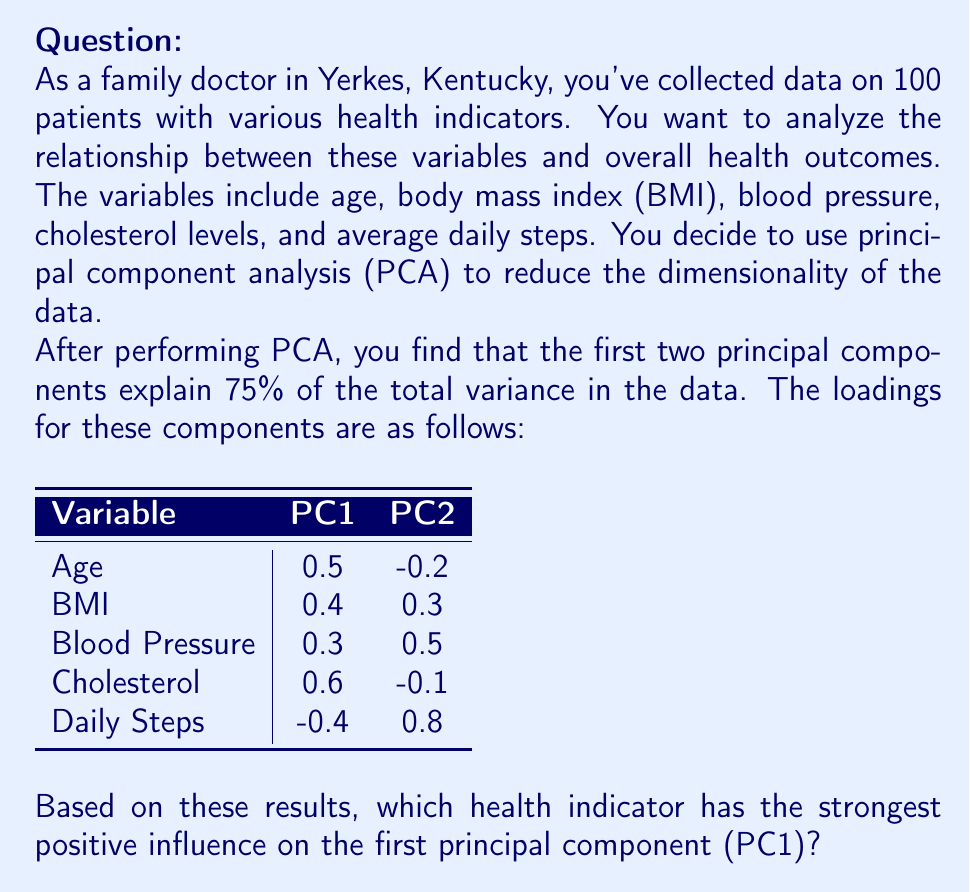Provide a solution to this math problem. To determine which health indicator has the strongest positive influence on PC1, we need to analyze the loadings for each variable in the PC1 column. The loadings represent the correlation between the original variables and the principal components.

Let's examine the loadings for PC1:

1. Age: 0.5
2. BMI: 0.4
3. Blood Pressure: 0.3
4. Cholesterol: 0.6
5. Daily Steps: -0.4

The largest positive loading for PC1 is 0.6, which corresponds to the Cholesterol variable. This means that Cholesterol has the strongest positive influence on the first principal component.

It's worth noting that:
- A positive loading indicates a positive correlation with the principal component.
- The larger the absolute value of the loading, the stronger the influence of that variable on the principal component.
- Daily Steps has a negative loading, indicating an inverse relationship with PC1.

In the context of your medical practice in Yerkes, Kentucky, this suggests that cholesterol levels are the most influential factor in explaining the variation in your patients' health data for the first principal component.
Answer: Cholesterol 